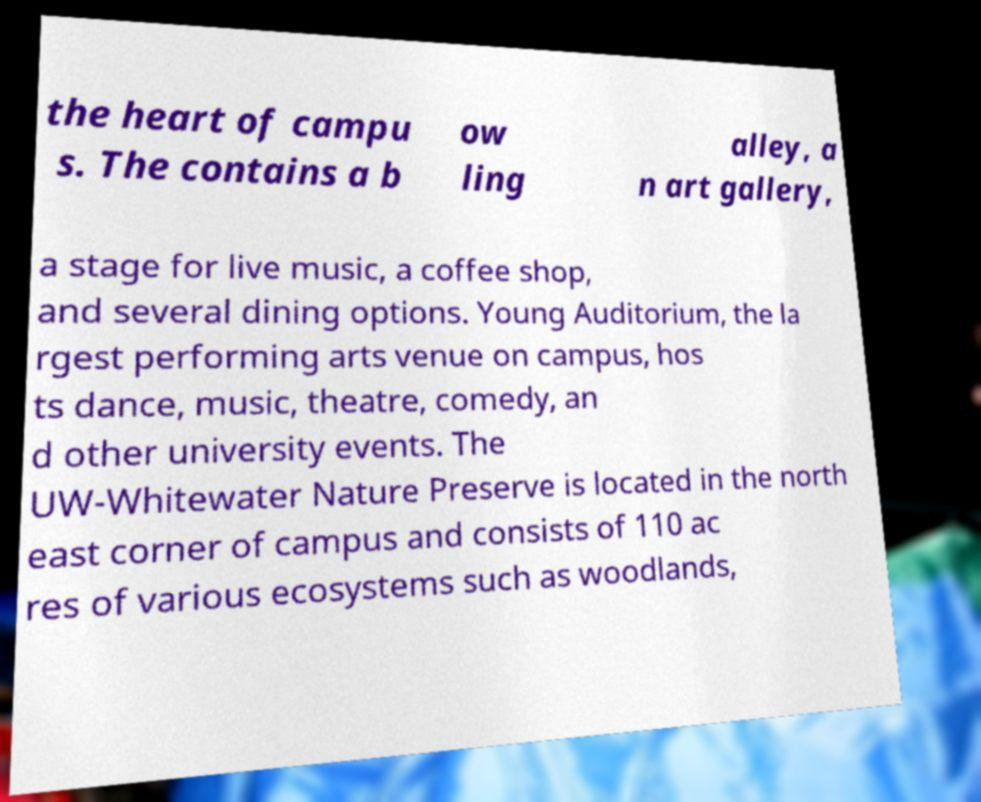Can you read and provide the text displayed in the image?This photo seems to have some interesting text. Can you extract and type it out for me? the heart of campu s. The contains a b ow ling alley, a n art gallery, a stage for live music, a coffee shop, and several dining options. Young Auditorium, the la rgest performing arts venue on campus, hos ts dance, music, theatre, comedy, an d other university events. The UW-Whitewater Nature Preserve is located in the north east corner of campus and consists of 110 ac res of various ecosystems such as woodlands, 